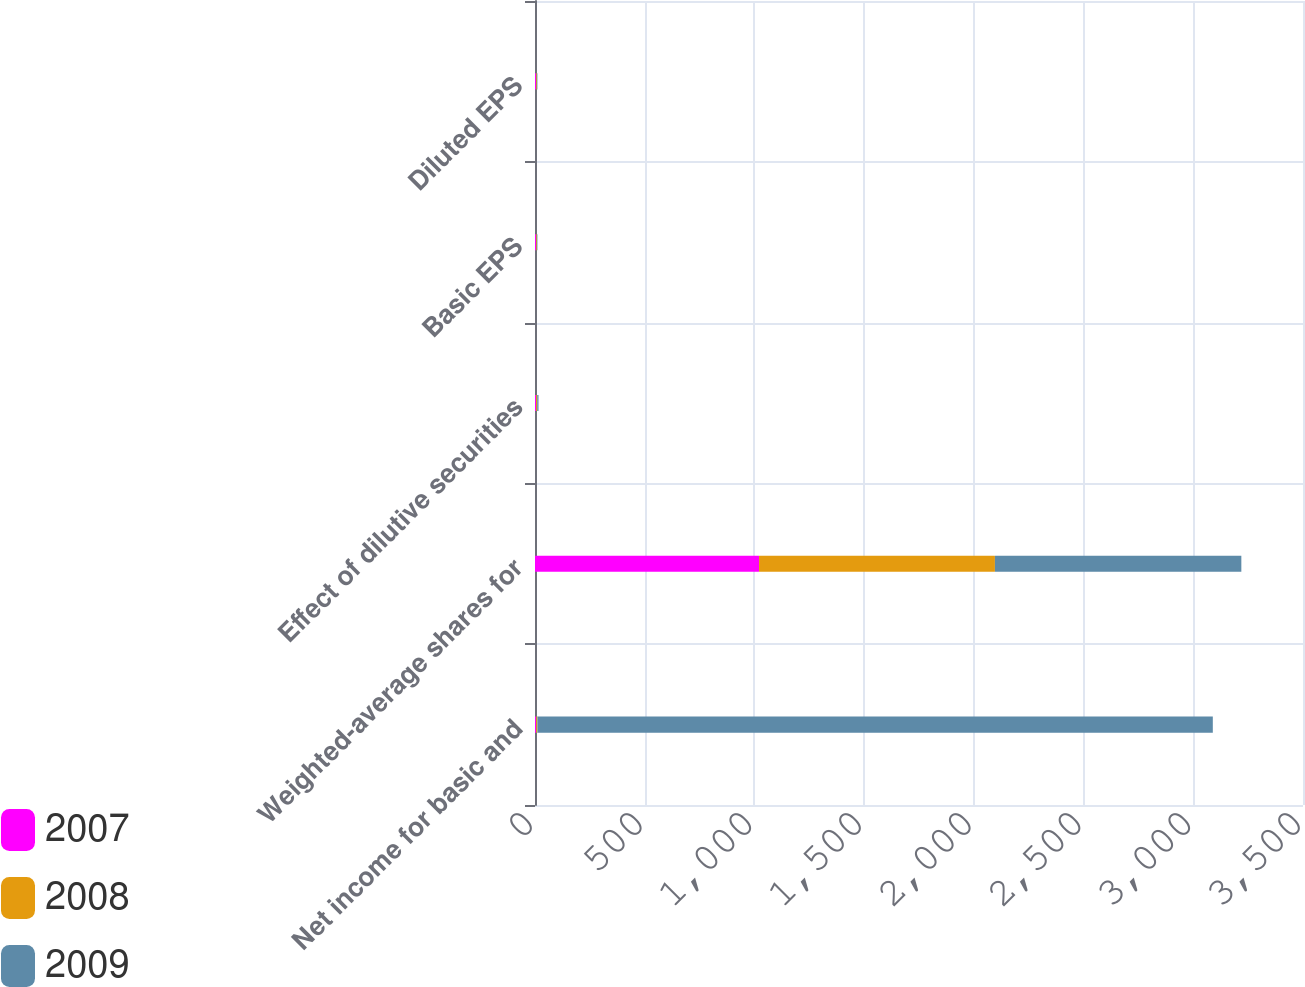<chart> <loc_0><loc_0><loc_500><loc_500><stacked_bar_chart><ecel><fcel>Net income for basic and<fcel>Weighted-average shares for<fcel>Effect of dilutive securities<fcel>Basic EPS<fcel>Diluted EPS<nl><fcel>2007<fcel>5.5<fcel>1021<fcel>5<fcel>4.53<fcel>4.51<nl><fcel>2008<fcel>5.5<fcel>1075<fcel>5<fcel>3.79<fcel>3.77<nl><fcel>2009<fcel>3078<fcel>1123<fcel>6<fcel>2.76<fcel>2.74<nl></chart> 